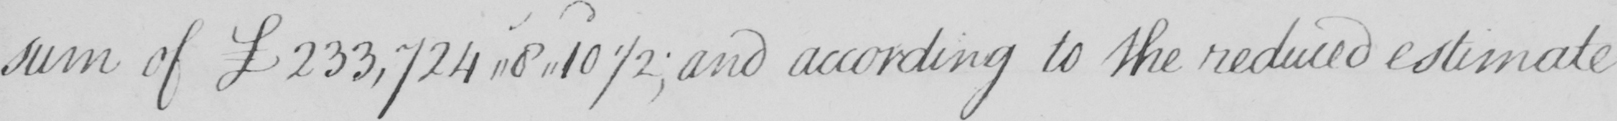Transcribe the text shown in this historical manuscript line. sum of £233,724,,8,,10 1/2  ; and according to the reduced estimate 